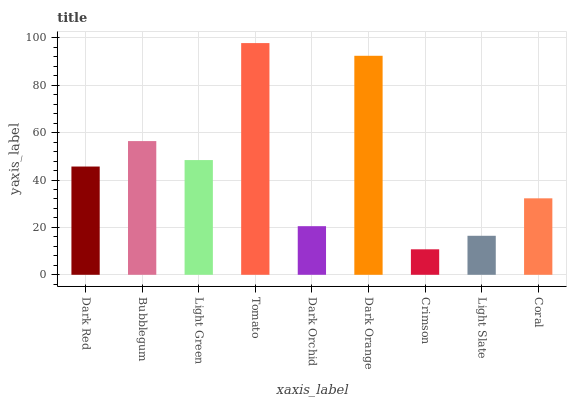Is Crimson the minimum?
Answer yes or no. Yes. Is Tomato the maximum?
Answer yes or no. Yes. Is Bubblegum the minimum?
Answer yes or no. No. Is Bubblegum the maximum?
Answer yes or no. No. Is Bubblegum greater than Dark Red?
Answer yes or no. Yes. Is Dark Red less than Bubblegum?
Answer yes or no. Yes. Is Dark Red greater than Bubblegum?
Answer yes or no. No. Is Bubblegum less than Dark Red?
Answer yes or no. No. Is Dark Red the high median?
Answer yes or no. Yes. Is Dark Red the low median?
Answer yes or no. Yes. Is Dark Orange the high median?
Answer yes or no. No. Is Light Green the low median?
Answer yes or no. No. 